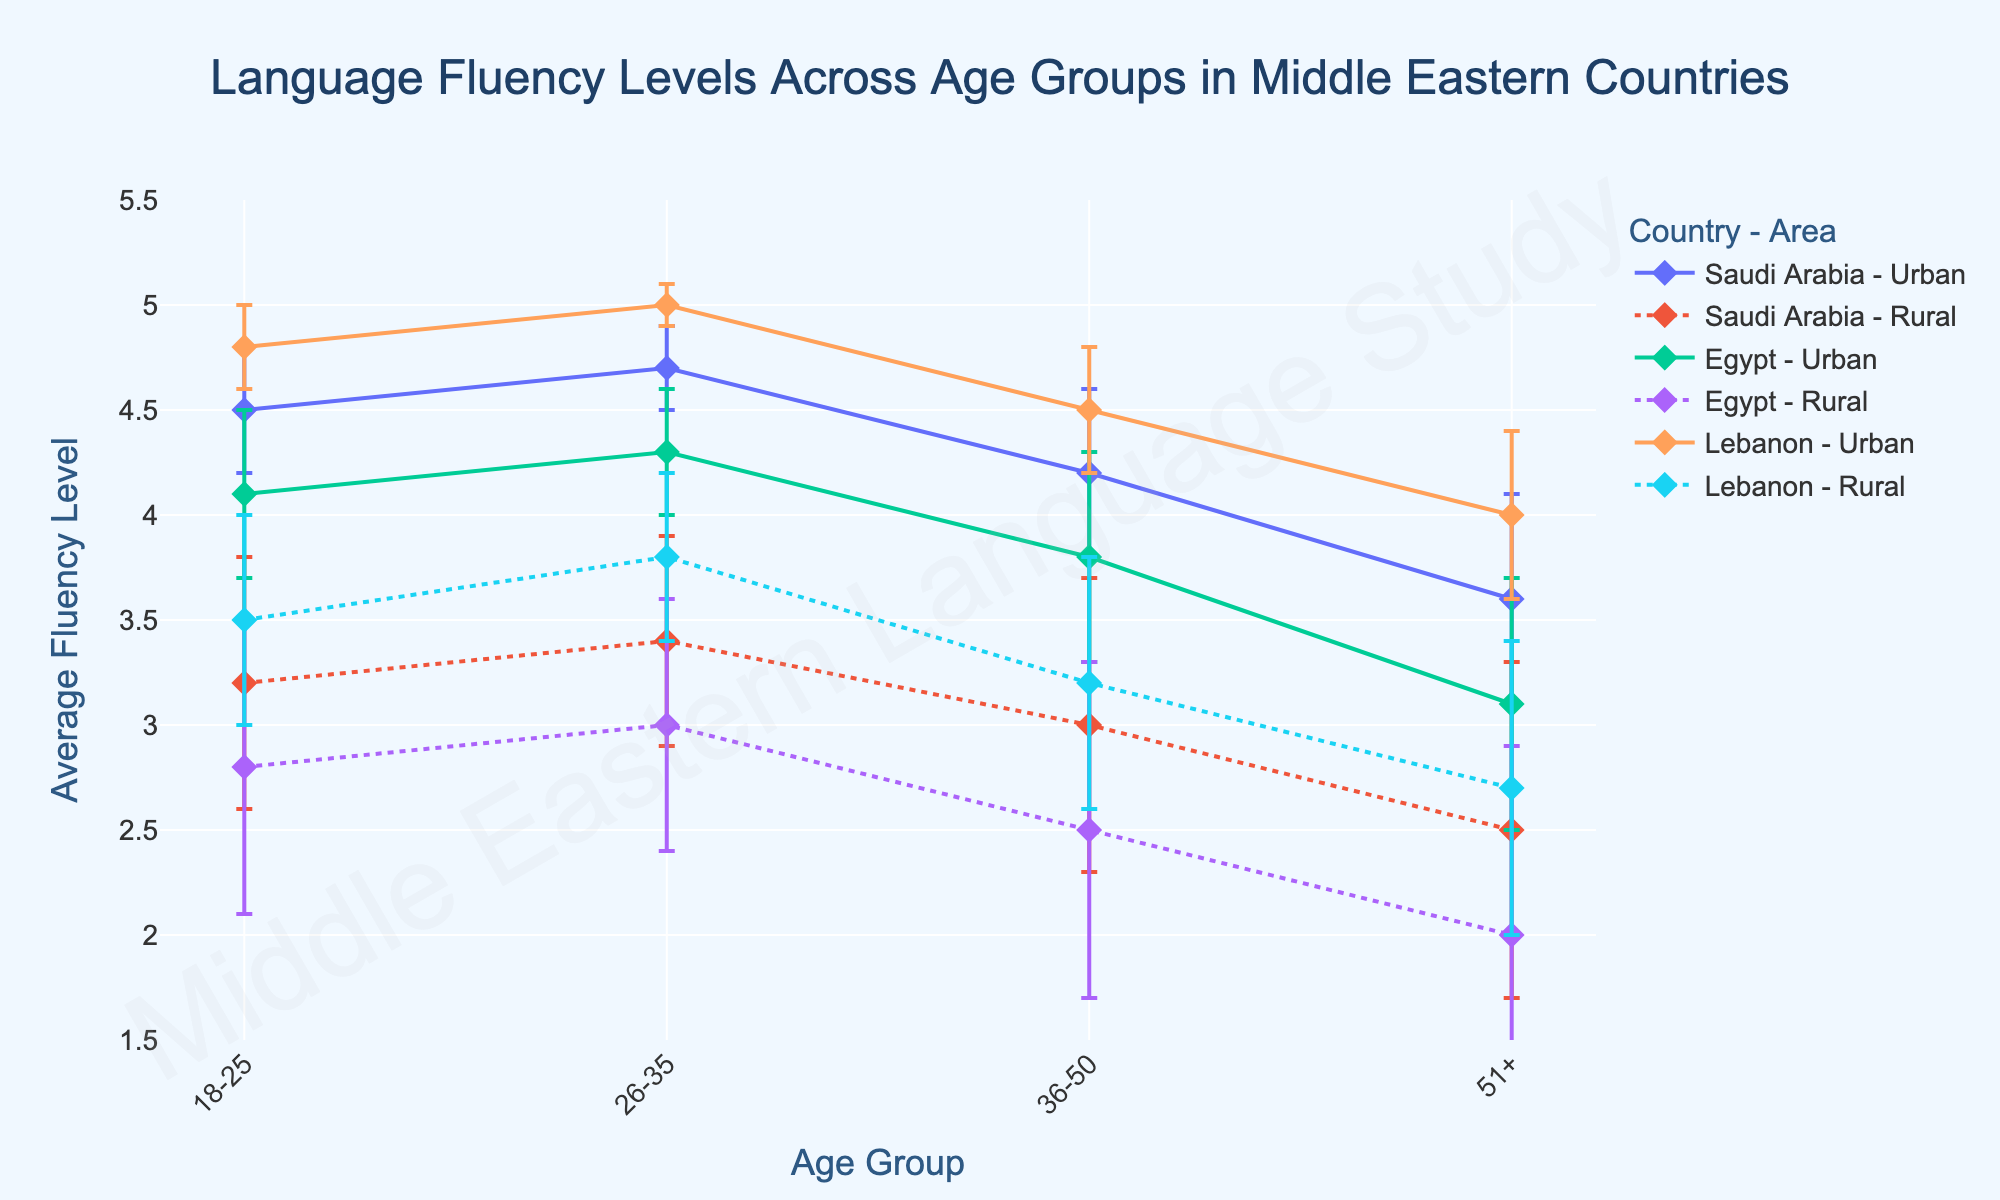What's the title of the plot? The title is typically displayed at the top of the figure and provides a brief description of the content being depicted. Here, it states the context and subject of the data being represented.
Answer: Language Fluency Levels Across Age Groups in Middle Eastern Countries What are the x-axis and y-axis titles? The x-axis title indicates the categorical variable. Here, it's "Age Group" depicting different age brackets. The y-axis title shows the quantitative variable being measured, which is "Average Fluency Level".
Answer: Age Group, Average Fluency Level Which country and area combination shows the highest average fluency level for 18-25 age group? To determine this, check the markers for the 18-25 age group across different country-area combinations, then identify the highest point. Lebanon Urban shows the highest level of 4.8 for this age group.
Answer: Lebanon Urban How does the average fluency level for the rural area in Saudi Arabia for the 36-50 age group compare to the urban area? Compare the markers for the age group 36-50 in Saudi Arabia for both Rural and Urban areas. The Urban area is at 4.2, while the Rural area is at 3.0.
Answer: Urban is higher Which age group in Egypt's rural areas has the lowest average fluency level? Examine the data points for Egypt Rural across all age groups, identifying the lowest marker. The 51+ age group has the lowest level at 2.0.
Answer: 51+ What is the difference in average fluency levels between the 18-25 and 51+ age groups in Egypt's Urban areas? Find the markers for 18-25 and 51+ age groups in Egypt Urban. The values are 4.1 and 3.1 respectively. Subtract the values: 4.1 - 3.1 = 1.
Answer: 1 What is the trend of average fluency levels as age increases in Lebanon's Urban area? Observe the markers for Lebanon Urban as age increases from 18-25 to 51+. The values are 4.8, 5.0, 4.5, and 4.0 respectively, indicating a slight increase followed by a decrease.
Answer: Decreases after 26-35 How does the average fluency level in Saudi Arabia's Rural area for the 26-35 age group compare to Egypt's Rural area for the same age group? Look at the markers for the 26-35 age group in both Saudi Arabia Rural and Egypt Rural areas. The values are 3.4 for Saudi Arabia Rural and 3.0 for Egypt Rural.
Answer: Saudi Arabia Rural is higher What could be the potential reason behind adding error bars in this plot? Error bars represent the variability of data and provide an understanding of how much uncertainty is associated with each average fluency level measurement, signified by the standard deviation.
Answer: Show data variability 